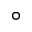<formula> <loc_0><loc_0><loc_500><loc_500>^ { \circ }</formula> 